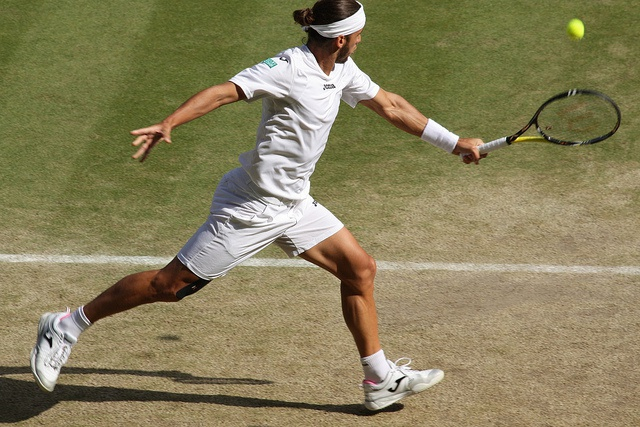Describe the objects in this image and their specific colors. I can see people in darkgreen, lightgray, gray, darkgray, and black tones, tennis racket in darkgreen, olive, and black tones, and sports ball in darkgreen, yellow, and olive tones in this image. 